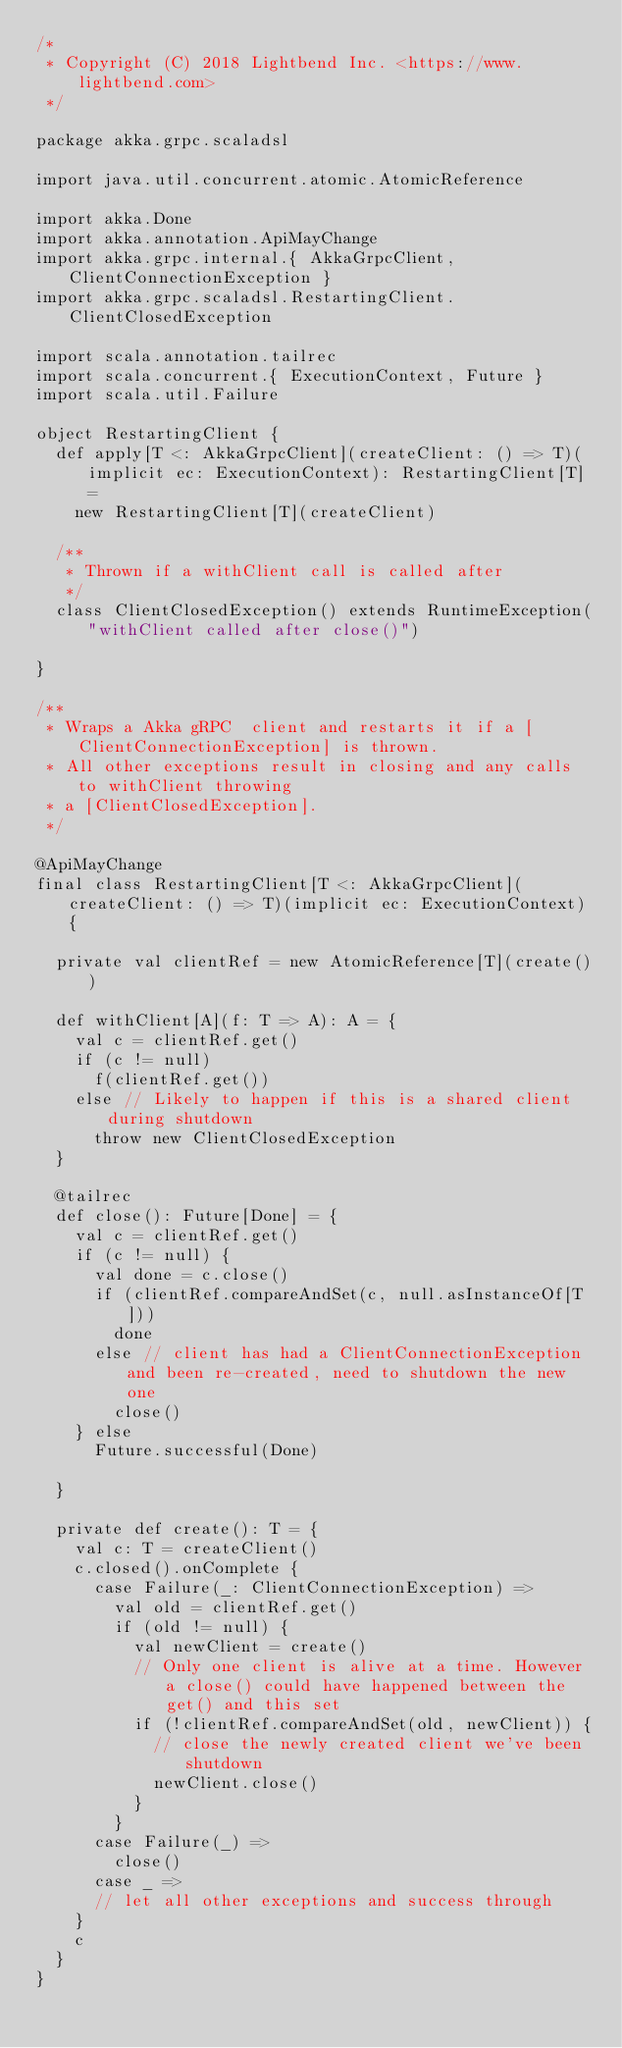<code> <loc_0><loc_0><loc_500><loc_500><_Scala_>/*
 * Copyright (C) 2018 Lightbend Inc. <https://www.lightbend.com>
 */

package akka.grpc.scaladsl

import java.util.concurrent.atomic.AtomicReference

import akka.Done
import akka.annotation.ApiMayChange
import akka.grpc.internal.{ AkkaGrpcClient, ClientConnectionException }
import akka.grpc.scaladsl.RestartingClient.ClientClosedException

import scala.annotation.tailrec
import scala.concurrent.{ ExecutionContext, Future }
import scala.util.Failure

object RestartingClient {
  def apply[T <: AkkaGrpcClient](createClient: () => T)(implicit ec: ExecutionContext): RestartingClient[T] =
    new RestartingClient[T](createClient)

  /**
   * Thrown if a withClient call is called after
   */
  class ClientClosedException() extends RuntimeException("withClient called after close()")

}

/**
 * Wraps a Akka gRPC  client and restarts it if a [ClientConnectionException] is thrown.
 * All other exceptions result in closing and any calls to withClient throwing
 * a [ClientClosedException].
 */

@ApiMayChange
final class RestartingClient[T <: AkkaGrpcClient](createClient: () => T)(implicit ec: ExecutionContext) {

  private val clientRef = new AtomicReference[T](create())

  def withClient[A](f: T => A): A = {
    val c = clientRef.get()
    if (c != null)
      f(clientRef.get())
    else // Likely to happen if this is a shared client during shutdown
      throw new ClientClosedException
  }

  @tailrec
  def close(): Future[Done] = {
    val c = clientRef.get()
    if (c != null) {
      val done = c.close()
      if (clientRef.compareAndSet(c, null.asInstanceOf[T]))
        done
      else // client has had a ClientConnectionException and been re-created, need to shutdown the new one
        close()
    } else
      Future.successful(Done)

  }

  private def create(): T = {
    val c: T = createClient()
    c.closed().onComplete {
      case Failure(_: ClientConnectionException) =>
        val old = clientRef.get()
        if (old != null) {
          val newClient = create()
          // Only one client is alive at a time. However a close() could have happened between the get() and this set
          if (!clientRef.compareAndSet(old, newClient)) {
            // close the newly created client we've been shutdown
            newClient.close()
          }
        }
      case Failure(_) =>
        close()
      case _ =>
      // let all other exceptions and success through
    }
    c
  }
}

</code> 